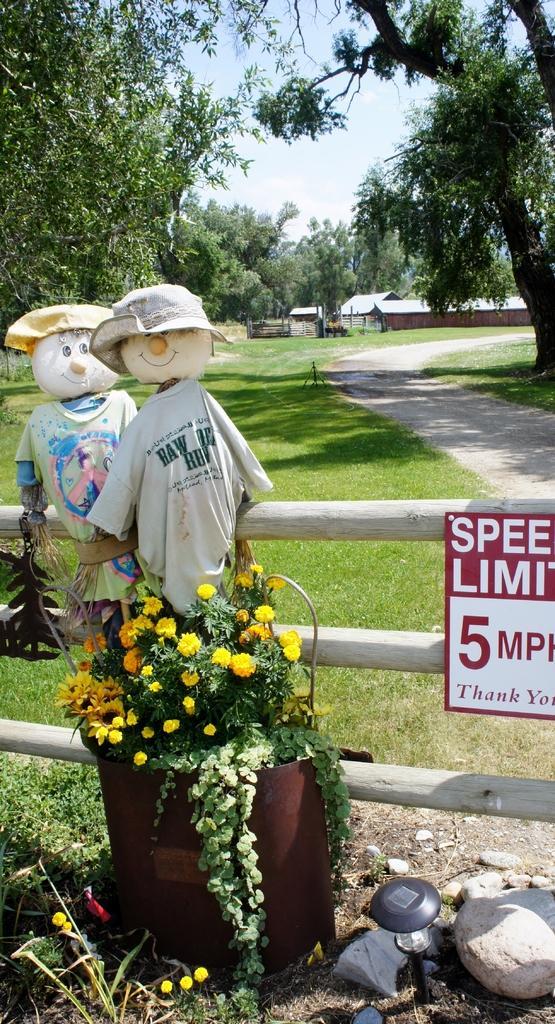Describe this image in one or two sentences. In this image in the foreground there is a fence, board, toys, flower pot, plant and some grass and small stones. In the background there are houses and trees and a walkway, at the top of the image there is sky. 